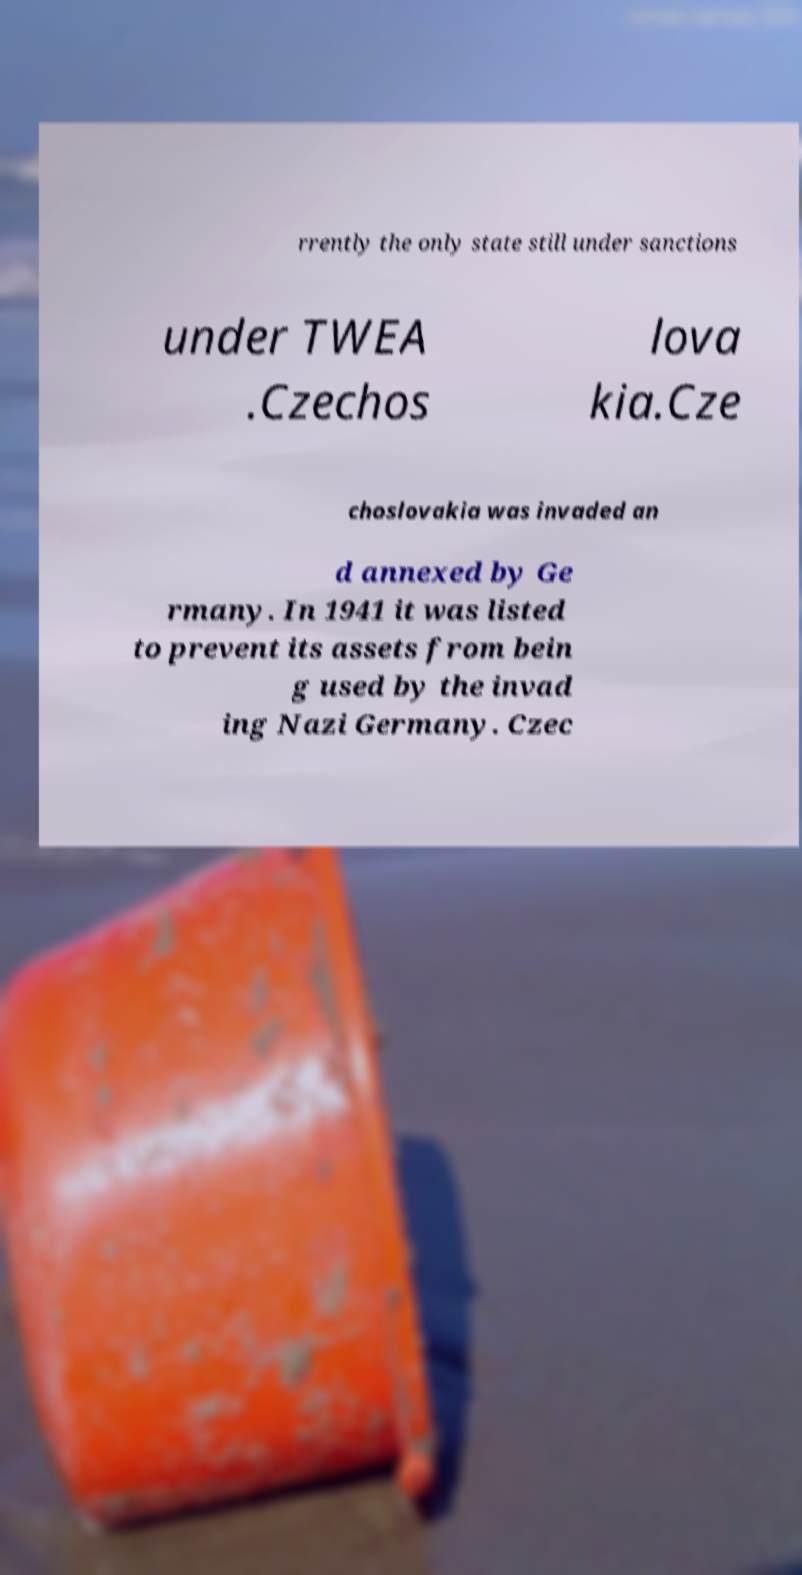Could you extract and type out the text from this image? rrently the only state still under sanctions under TWEA .Czechos lova kia.Cze choslovakia was invaded an d annexed by Ge rmany. In 1941 it was listed to prevent its assets from bein g used by the invad ing Nazi Germany. Czec 